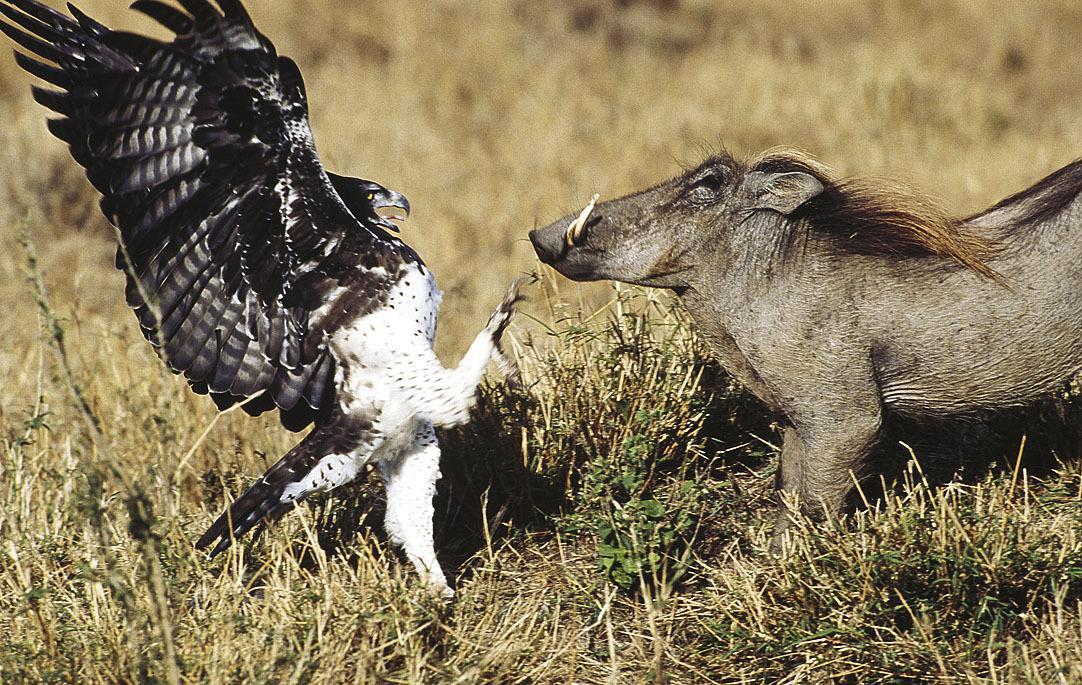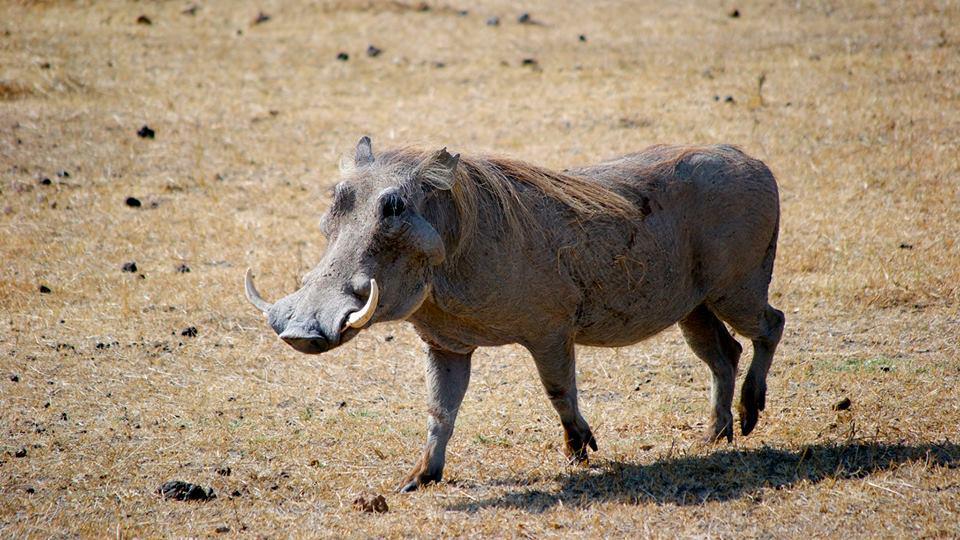The first image is the image on the left, the second image is the image on the right. Given the left and right images, does the statement "One image includes at least one bird with a standing warthog." hold true? Answer yes or no. Yes. The first image is the image on the left, the second image is the image on the right. Evaluate the accuracy of this statement regarding the images: "A boar is near the pig in one of the images.". Is it true? Answer yes or no. Yes. 